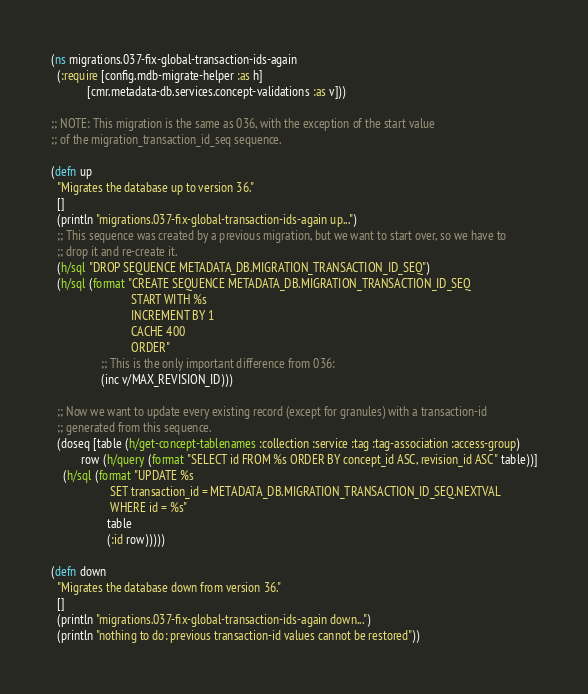Convert code to text. <code><loc_0><loc_0><loc_500><loc_500><_Clojure_>(ns migrations.037-fix-global-transaction-ids-again
  (:require [config.mdb-migrate-helper :as h]
            [cmr.metadata-db.services.concept-validations :as v]))

;; NOTE: This migration is the same as 036, with the exception of the start value
;; of the migration_transaction_id_seq sequence.

(defn up
  "Migrates the database up to version 36."
  []
  (println "migrations.037-fix-global-transaction-ids-again up...")
  ;; This sequence was created by a previous migration, but we want to start over, so we have to
  ;; drop it and re-create it.
  (h/sql "DROP SEQUENCE METADATA_DB.MIGRATION_TRANSACTION_ID_SEQ")
  (h/sql (format "CREATE SEQUENCE METADATA_DB.MIGRATION_TRANSACTION_ID_SEQ
                           START WITH %s
                           INCREMENT BY 1
                           CACHE 400
                           ORDER"
                 ;; This is the only important difference from 036:
                 (inc v/MAX_REVISION_ID)))

  ;; Now we want to update every existing record (except for granules) with a transaction-id
  ;; generated from this sequence.
  (doseq [table (h/get-concept-tablenames :collection :service :tag :tag-association :access-group)
          row (h/query (format "SELECT id FROM %s ORDER BY concept_id ASC, revision_id ASC" table))]
    (h/sql (format "UPDATE %s
                    SET transaction_id = METADATA_DB.MIGRATION_TRANSACTION_ID_SEQ.NEXTVAL
                    WHERE id = %s"
                   table
                   (:id row)))))

(defn down
  "Migrates the database down from version 36."
  []
  (println "migrations.037-fix-global-transaction-ids-again down...")
  (println "nothing to do: previous transaction-id values cannot be restored"))
</code> 